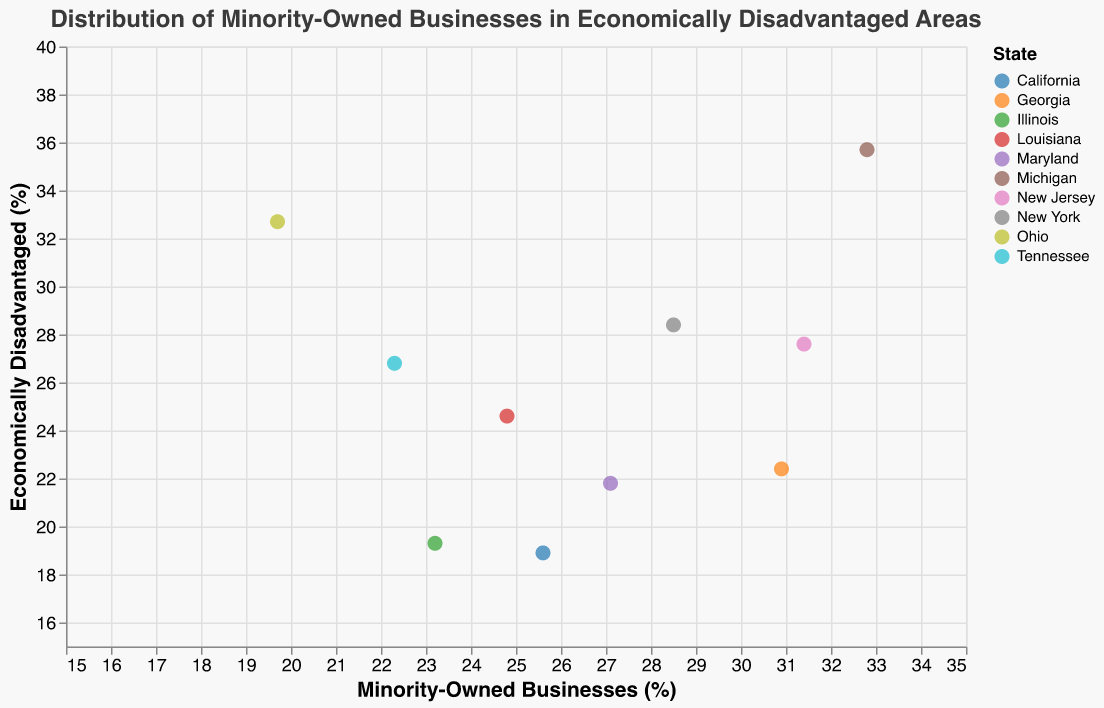What is the title of the plot? The title is the text at the top of the plot.
Answer: Distribution of Minority-Owned Businesses in Economically Disadvantaged Areas Which city has the highest percentage of minority-owned businesses? By looking at the x-axis, find the city that is located the farthest to the right.
Answer: Detroit Which city has the highest percentage of economically disadvantaged areas? By looking at the y-axis, find the city that is located at the topmost point.
Answer: Detroit Are there any cities where the percentage of minority-owned businesses is higher than the percentage of economically disadvantaged areas? Compare the x-axis values with the y-axis values for each city.
Answer: Yes, Oakland, Atlanta, Baltimore, and Chicago Which state has the most cities represented in the plot? Identify the state that appears most frequently in the legend.
Answer: New York What is the average percentage of minority-owned businesses in all cities? Sum up all x-axis values and divide by the number of cities (10).
Answer: 26.63% How does the percentage of minority-owned businesses in Newark compare to that in Atlanta? Compare the x-axis positions of the points representing Newark and Atlanta.
Answer: Newark has a higher percentage Which city is closest to having an equal percentage of minority-owned businesses and economically disadvantaged areas? Look for the city where the x-value and y-value are closest together.
Answer: Bronx What is the range of economically disadvantaged areas (%) across all cities? Subtract the smallest y-axis value from the largest y-axis value.
Answer: 16.8% Is there a positive correlation between the percentage of minority-owned businesses and economically disadvantaged areas? Check if cities with higher minority-owned businesses also have higher economically disadvantaged areas.
Answer: No, there is no strong correlation 